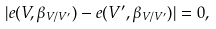<formula> <loc_0><loc_0><loc_500><loc_500>| e ( V , \beta _ { V / V ^ { \prime } } ) - e ( V ^ { \prime } , \beta _ { V / V ^ { \prime } } ) | = 0 ,</formula> 